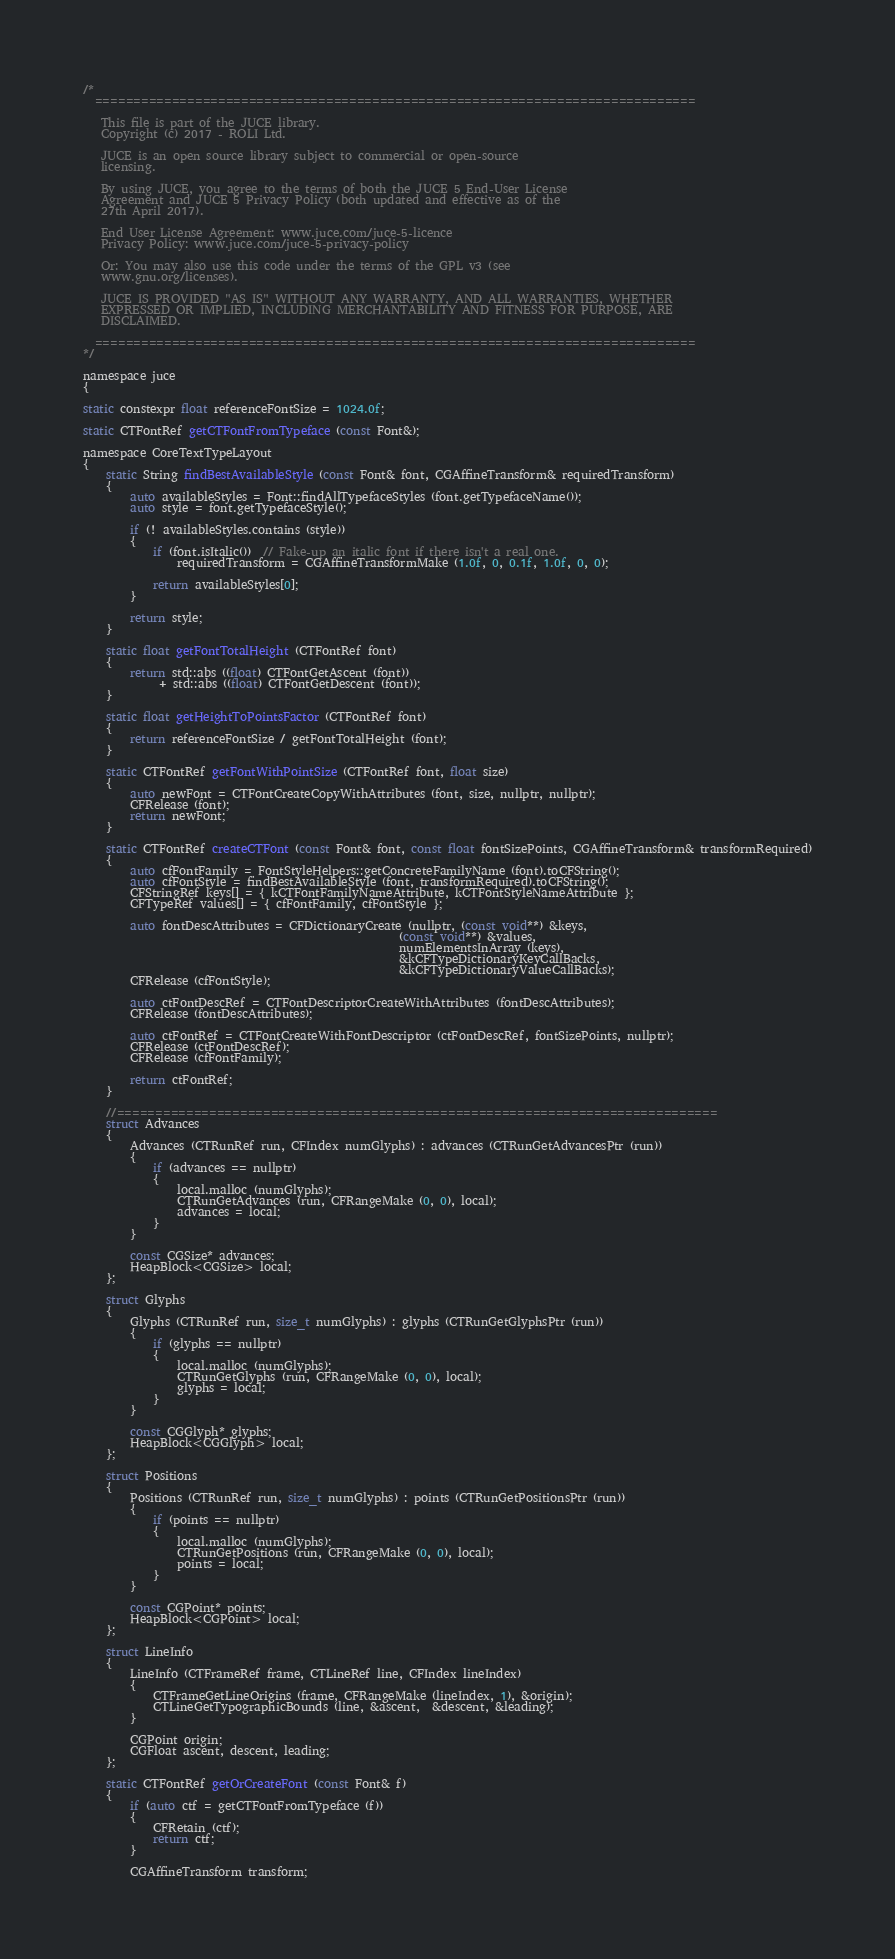<code> <loc_0><loc_0><loc_500><loc_500><_ObjectiveC_>/*
  ==============================================================================

   This file is part of the JUCE library.
   Copyright (c) 2017 - ROLI Ltd.

   JUCE is an open source library subject to commercial or open-source
   licensing.

   By using JUCE, you agree to the terms of both the JUCE 5 End-User License
   Agreement and JUCE 5 Privacy Policy (both updated and effective as of the
   27th April 2017).

   End User License Agreement: www.juce.com/juce-5-licence
   Privacy Policy: www.juce.com/juce-5-privacy-policy

   Or: You may also use this code under the terms of the GPL v3 (see
   www.gnu.org/licenses).

   JUCE IS PROVIDED "AS IS" WITHOUT ANY WARRANTY, AND ALL WARRANTIES, WHETHER
   EXPRESSED OR IMPLIED, INCLUDING MERCHANTABILITY AND FITNESS FOR PURPOSE, ARE
   DISCLAIMED.

  ==============================================================================
*/

namespace juce
{

static constexpr float referenceFontSize = 1024.0f;

static CTFontRef getCTFontFromTypeface (const Font&);

namespace CoreTextTypeLayout
{
    static String findBestAvailableStyle (const Font& font, CGAffineTransform& requiredTransform)
    {
        auto availableStyles = Font::findAllTypefaceStyles (font.getTypefaceName());
        auto style = font.getTypefaceStyle();

        if (! availableStyles.contains (style))
        {
            if (font.isItalic())  // Fake-up an italic font if there isn't a real one.
                requiredTransform = CGAffineTransformMake (1.0f, 0, 0.1f, 1.0f, 0, 0);

            return availableStyles[0];
        }

        return style;
    }

    static float getFontTotalHeight (CTFontRef font)
    {
        return std::abs ((float) CTFontGetAscent (font))
             + std::abs ((float) CTFontGetDescent (font));
    }

    static float getHeightToPointsFactor (CTFontRef font)
    {
        return referenceFontSize / getFontTotalHeight (font);
    }

    static CTFontRef getFontWithPointSize (CTFontRef font, float size)
    {
        auto newFont = CTFontCreateCopyWithAttributes (font, size, nullptr, nullptr);
        CFRelease (font);
        return newFont;
    }

    static CTFontRef createCTFont (const Font& font, const float fontSizePoints, CGAffineTransform& transformRequired)
    {
        auto cfFontFamily = FontStyleHelpers::getConcreteFamilyName (font).toCFString();
        auto cfFontStyle = findBestAvailableStyle (font, transformRequired).toCFString();
        CFStringRef keys[] = { kCTFontFamilyNameAttribute, kCTFontStyleNameAttribute };
        CFTypeRef values[] = { cfFontFamily, cfFontStyle };

        auto fontDescAttributes = CFDictionaryCreate (nullptr, (const void**) &keys,
                                                      (const void**) &values,
                                                      numElementsInArray (keys),
                                                      &kCFTypeDictionaryKeyCallBacks,
                                                      &kCFTypeDictionaryValueCallBacks);
        CFRelease (cfFontStyle);

        auto ctFontDescRef = CTFontDescriptorCreateWithAttributes (fontDescAttributes);
        CFRelease (fontDescAttributes);

        auto ctFontRef = CTFontCreateWithFontDescriptor (ctFontDescRef, fontSizePoints, nullptr);
        CFRelease (ctFontDescRef);
        CFRelease (cfFontFamily);

        return ctFontRef;
    }

    //==============================================================================
    struct Advances
    {
        Advances (CTRunRef run, CFIndex numGlyphs) : advances (CTRunGetAdvancesPtr (run))
        {
            if (advances == nullptr)
            {
                local.malloc (numGlyphs);
                CTRunGetAdvances (run, CFRangeMake (0, 0), local);
                advances = local;
            }
        }

        const CGSize* advances;
        HeapBlock<CGSize> local;
    };

    struct Glyphs
    {
        Glyphs (CTRunRef run, size_t numGlyphs) : glyphs (CTRunGetGlyphsPtr (run))
        {
            if (glyphs == nullptr)
            {
                local.malloc (numGlyphs);
                CTRunGetGlyphs (run, CFRangeMake (0, 0), local);
                glyphs = local;
            }
        }

        const CGGlyph* glyphs;
        HeapBlock<CGGlyph> local;
    };

    struct Positions
    {
        Positions (CTRunRef run, size_t numGlyphs) : points (CTRunGetPositionsPtr (run))
        {
            if (points == nullptr)
            {
                local.malloc (numGlyphs);
                CTRunGetPositions (run, CFRangeMake (0, 0), local);
                points = local;
            }
        }

        const CGPoint* points;
        HeapBlock<CGPoint> local;
    };

    struct LineInfo
    {
        LineInfo (CTFrameRef frame, CTLineRef line, CFIndex lineIndex)
        {
            CTFrameGetLineOrigins (frame, CFRangeMake (lineIndex, 1), &origin);
            CTLineGetTypographicBounds (line, &ascent,  &descent, &leading);
        }

        CGPoint origin;
        CGFloat ascent, descent, leading;
    };

    static CTFontRef getOrCreateFont (const Font& f)
    {
        if (auto ctf = getCTFontFromTypeface (f))
        {
            CFRetain (ctf);
            return ctf;
        }

        CGAffineTransform transform;</code> 